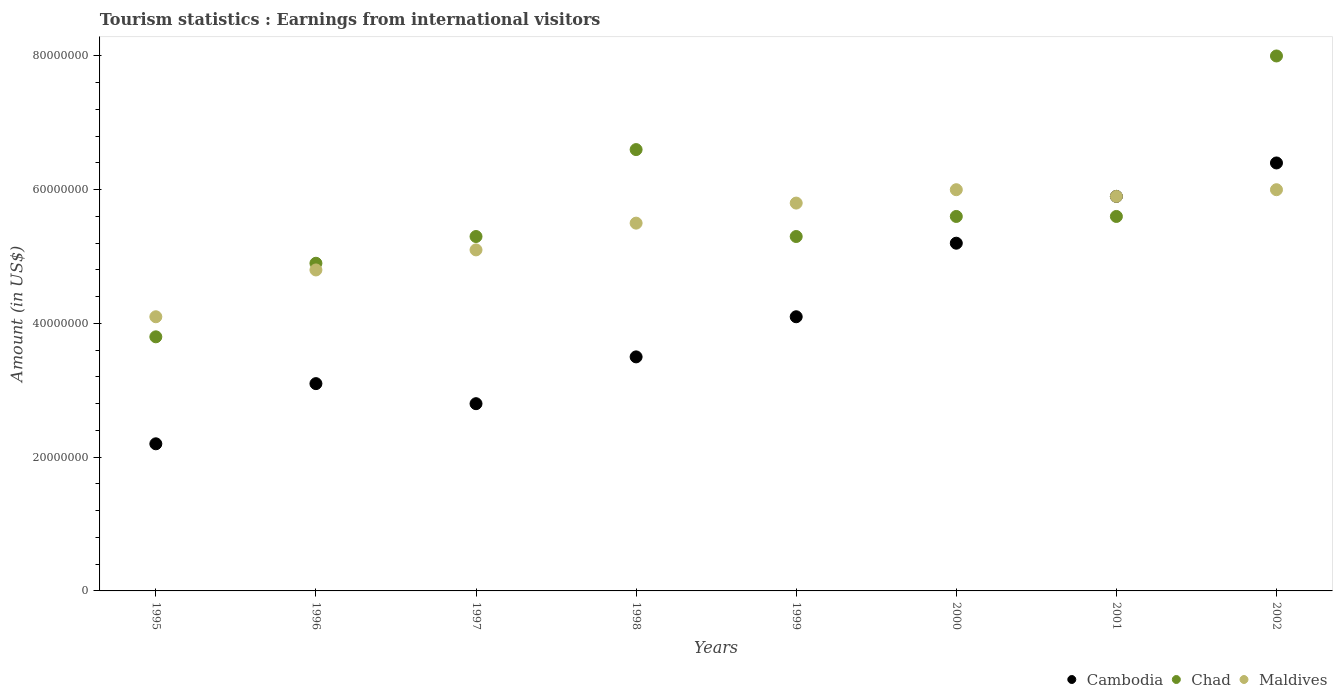How many different coloured dotlines are there?
Offer a terse response. 3. What is the earnings from international visitors in Cambodia in 2000?
Make the answer very short. 5.20e+07. Across all years, what is the maximum earnings from international visitors in Cambodia?
Keep it short and to the point. 6.40e+07. Across all years, what is the minimum earnings from international visitors in Chad?
Offer a very short reply. 3.80e+07. What is the total earnings from international visitors in Maldives in the graph?
Provide a short and direct response. 4.32e+08. What is the difference between the earnings from international visitors in Chad in 2000 and that in 2002?
Provide a short and direct response. -2.40e+07. What is the difference between the earnings from international visitors in Chad in 2001 and the earnings from international visitors in Cambodia in 1996?
Your answer should be compact. 2.50e+07. What is the average earnings from international visitors in Maldives per year?
Keep it short and to the point. 5.40e+07. In the year 1997, what is the difference between the earnings from international visitors in Maldives and earnings from international visitors in Chad?
Your response must be concise. -2.00e+06. In how many years, is the earnings from international visitors in Chad greater than 52000000 US$?
Ensure brevity in your answer.  6. What is the ratio of the earnings from international visitors in Maldives in 2001 to that in 2002?
Offer a very short reply. 0.98. What is the difference between the highest and the lowest earnings from international visitors in Maldives?
Ensure brevity in your answer.  1.90e+07. Is the sum of the earnings from international visitors in Maldives in 1995 and 1998 greater than the maximum earnings from international visitors in Cambodia across all years?
Your response must be concise. Yes. What is the difference between two consecutive major ticks on the Y-axis?
Your response must be concise. 2.00e+07. Does the graph contain grids?
Your response must be concise. No. How are the legend labels stacked?
Give a very brief answer. Horizontal. What is the title of the graph?
Offer a terse response. Tourism statistics : Earnings from international visitors. Does "Lower middle income" appear as one of the legend labels in the graph?
Keep it short and to the point. No. What is the label or title of the Y-axis?
Keep it short and to the point. Amount (in US$). What is the Amount (in US$) of Cambodia in 1995?
Your answer should be compact. 2.20e+07. What is the Amount (in US$) of Chad in 1995?
Offer a terse response. 3.80e+07. What is the Amount (in US$) in Maldives in 1995?
Your answer should be very brief. 4.10e+07. What is the Amount (in US$) in Cambodia in 1996?
Your response must be concise. 3.10e+07. What is the Amount (in US$) in Chad in 1996?
Ensure brevity in your answer.  4.90e+07. What is the Amount (in US$) of Maldives in 1996?
Make the answer very short. 4.80e+07. What is the Amount (in US$) in Cambodia in 1997?
Give a very brief answer. 2.80e+07. What is the Amount (in US$) in Chad in 1997?
Provide a succinct answer. 5.30e+07. What is the Amount (in US$) of Maldives in 1997?
Offer a very short reply. 5.10e+07. What is the Amount (in US$) in Cambodia in 1998?
Ensure brevity in your answer.  3.50e+07. What is the Amount (in US$) of Chad in 1998?
Provide a succinct answer. 6.60e+07. What is the Amount (in US$) in Maldives in 1998?
Give a very brief answer. 5.50e+07. What is the Amount (in US$) in Cambodia in 1999?
Offer a very short reply. 4.10e+07. What is the Amount (in US$) of Chad in 1999?
Your answer should be very brief. 5.30e+07. What is the Amount (in US$) of Maldives in 1999?
Offer a very short reply. 5.80e+07. What is the Amount (in US$) in Cambodia in 2000?
Your response must be concise. 5.20e+07. What is the Amount (in US$) of Chad in 2000?
Ensure brevity in your answer.  5.60e+07. What is the Amount (in US$) in Maldives in 2000?
Provide a short and direct response. 6.00e+07. What is the Amount (in US$) of Cambodia in 2001?
Ensure brevity in your answer.  5.90e+07. What is the Amount (in US$) of Chad in 2001?
Provide a succinct answer. 5.60e+07. What is the Amount (in US$) of Maldives in 2001?
Offer a very short reply. 5.90e+07. What is the Amount (in US$) of Cambodia in 2002?
Your answer should be very brief. 6.40e+07. What is the Amount (in US$) of Chad in 2002?
Your answer should be compact. 8.00e+07. What is the Amount (in US$) in Maldives in 2002?
Offer a very short reply. 6.00e+07. Across all years, what is the maximum Amount (in US$) of Cambodia?
Give a very brief answer. 6.40e+07. Across all years, what is the maximum Amount (in US$) of Chad?
Ensure brevity in your answer.  8.00e+07. Across all years, what is the maximum Amount (in US$) in Maldives?
Ensure brevity in your answer.  6.00e+07. Across all years, what is the minimum Amount (in US$) of Cambodia?
Offer a very short reply. 2.20e+07. Across all years, what is the minimum Amount (in US$) of Chad?
Your answer should be very brief. 3.80e+07. Across all years, what is the minimum Amount (in US$) of Maldives?
Your answer should be very brief. 4.10e+07. What is the total Amount (in US$) in Cambodia in the graph?
Your response must be concise. 3.32e+08. What is the total Amount (in US$) of Chad in the graph?
Your answer should be compact. 4.51e+08. What is the total Amount (in US$) of Maldives in the graph?
Offer a very short reply. 4.32e+08. What is the difference between the Amount (in US$) of Cambodia in 1995 and that in 1996?
Make the answer very short. -9.00e+06. What is the difference between the Amount (in US$) in Chad in 1995 and that in 1996?
Your answer should be compact. -1.10e+07. What is the difference between the Amount (in US$) of Maldives in 1995 and that in 1996?
Offer a very short reply. -7.00e+06. What is the difference between the Amount (in US$) of Cambodia in 1995 and that in 1997?
Give a very brief answer. -6.00e+06. What is the difference between the Amount (in US$) in Chad in 1995 and that in 1997?
Offer a terse response. -1.50e+07. What is the difference between the Amount (in US$) of Maldives in 1995 and that in 1997?
Keep it short and to the point. -1.00e+07. What is the difference between the Amount (in US$) of Cambodia in 1995 and that in 1998?
Your answer should be compact. -1.30e+07. What is the difference between the Amount (in US$) in Chad in 1995 and that in 1998?
Give a very brief answer. -2.80e+07. What is the difference between the Amount (in US$) in Maldives in 1995 and that in 1998?
Make the answer very short. -1.40e+07. What is the difference between the Amount (in US$) of Cambodia in 1995 and that in 1999?
Ensure brevity in your answer.  -1.90e+07. What is the difference between the Amount (in US$) of Chad in 1995 and that in 1999?
Your response must be concise. -1.50e+07. What is the difference between the Amount (in US$) in Maldives in 1995 and that in 1999?
Your answer should be compact. -1.70e+07. What is the difference between the Amount (in US$) of Cambodia in 1995 and that in 2000?
Provide a succinct answer. -3.00e+07. What is the difference between the Amount (in US$) in Chad in 1995 and that in 2000?
Make the answer very short. -1.80e+07. What is the difference between the Amount (in US$) in Maldives in 1995 and that in 2000?
Ensure brevity in your answer.  -1.90e+07. What is the difference between the Amount (in US$) in Cambodia in 1995 and that in 2001?
Your response must be concise. -3.70e+07. What is the difference between the Amount (in US$) of Chad in 1995 and that in 2001?
Provide a succinct answer. -1.80e+07. What is the difference between the Amount (in US$) of Maldives in 1995 and that in 2001?
Offer a terse response. -1.80e+07. What is the difference between the Amount (in US$) in Cambodia in 1995 and that in 2002?
Ensure brevity in your answer.  -4.20e+07. What is the difference between the Amount (in US$) of Chad in 1995 and that in 2002?
Provide a succinct answer. -4.20e+07. What is the difference between the Amount (in US$) of Maldives in 1995 and that in 2002?
Your answer should be very brief. -1.90e+07. What is the difference between the Amount (in US$) of Cambodia in 1996 and that in 1997?
Provide a short and direct response. 3.00e+06. What is the difference between the Amount (in US$) in Maldives in 1996 and that in 1997?
Your answer should be very brief. -3.00e+06. What is the difference between the Amount (in US$) of Chad in 1996 and that in 1998?
Provide a succinct answer. -1.70e+07. What is the difference between the Amount (in US$) in Maldives in 1996 and that in 1998?
Your answer should be compact. -7.00e+06. What is the difference between the Amount (in US$) in Cambodia in 1996 and that in 1999?
Your answer should be very brief. -1.00e+07. What is the difference between the Amount (in US$) in Maldives in 1996 and that in 1999?
Your response must be concise. -1.00e+07. What is the difference between the Amount (in US$) in Cambodia in 1996 and that in 2000?
Your answer should be very brief. -2.10e+07. What is the difference between the Amount (in US$) of Chad in 1996 and that in 2000?
Offer a very short reply. -7.00e+06. What is the difference between the Amount (in US$) in Maldives in 1996 and that in 2000?
Ensure brevity in your answer.  -1.20e+07. What is the difference between the Amount (in US$) of Cambodia in 1996 and that in 2001?
Provide a succinct answer. -2.80e+07. What is the difference between the Amount (in US$) of Chad in 1996 and that in 2001?
Your answer should be compact. -7.00e+06. What is the difference between the Amount (in US$) of Maldives in 1996 and that in 2001?
Offer a terse response. -1.10e+07. What is the difference between the Amount (in US$) in Cambodia in 1996 and that in 2002?
Give a very brief answer. -3.30e+07. What is the difference between the Amount (in US$) in Chad in 1996 and that in 2002?
Your answer should be very brief. -3.10e+07. What is the difference between the Amount (in US$) of Maldives in 1996 and that in 2002?
Provide a succinct answer. -1.20e+07. What is the difference between the Amount (in US$) of Cambodia in 1997 and that in 1998?
Your answer should be very brief. -7.00e+06. What is the difference between the Amount (in US$) in Chad in 1997 and that in 1998?
Ensure brevity in your answer.  -1.30e+07. What is the difference between the Amount (in US$) of Maldives in 1997 and that in 1998?
Ensure brevity in your answer.  -4.00e+06. What is the difference between the Amount (in US$) of Cambodia in 1997 and that in 1999?
Keep it short and to the point. -1.30e+07. What is the difference between the Amount (in US$) in Chad in 1997 and that in 1999?
Provide a short and direct response. 0. What is the difference between the Amount (in US$) of Maldives in 1997 and that in 1999?
Give a very brief answer. -7.00e+06. What is the difference between the Amount (in US$) of Cambodia in 1997 and that in 2000?
Offer a very short reply. -2.40e+07. What is the difference between the Amount (in US$) in Chad in 1997 and that in 2000?
Your answer should be compact. -3.00e+06. What is the difference between the Amount (in US$) in Maldives in 1997 and that in 2000?
Ensure brevity in your answer.  -9.00e+06. What is the difference between the Amount (in US$) in Cambodia in 1997 and that in 2001?
Provide a succinct answer. -3.10e+07. What is the difference between the Amount (in US$) in Maldives in 1997 and that in 2001?
Offer a very short reply. -8.00e+06. What is the difference between the Amount (in US$) in Cambodia in 1997 and that in 2002?
Offer a terse response. -3.60e+07. What is the difference between the Amount (in US$) of Chad in 1997 and that in 2002?
Provide a succinct answer. -2.70e+07. What is the difference between the Amount (in US$) of Maldives in 1997 and that in 2002?
Provide a short and direct response. -9.00e+06. What is the difference between the Amount (in US$) of Cambodia in 1998 and that in 1999?
Give a very brief answer. -6.00e+06. What is the difference between the Amount (in US$) in Chad in 1998 and that in 1999?
Provide a short and direct response. 1.30e+07. What is the difference between the Amount (in US$) of Cambodia in 1998 and that in 2000?
Provide a short and direct response. -1.70e+07. What is the difference between the Amount (in US$) of Chad in 1998 and that in 2000?
Make the answer very short. 1.00e+07. What is the difference between the Amount (in US$) of Maldives in 1998 and that in 2000?
Offer a very short reply. -5.00e+06. What is the difference between the Amount (in US$) in Cambodia in 1998 and that in 2001?
Make the answer very short. -2.40e+07. What is the difference between the Amount (in US$) of Chad in 1998 and that in 2001?
Your answer should be very brief. 1.00e+07. What is the difference between the Amount (in US$) of Cambodia in 1998 and that in 2002?
Make the answer very short. -2.90e+07. What is the difference between the Amount (in US$) in Chad in 1998 and that in 2002?
Your response must be concise. -1.40e+07. What is the difference between the Amount (in US$) of Maldives in 1998 and that in 2002?
Ensure brevity in your answer.  -5.00e+06. What is the difference between the Amount (in US$) in Cambodia in 1999 and that in 2000?
Offer a terse response. -1.10e+07. What is the difference between the Amount (in US$) of Chad in 1999 and that in 2000?
Offer a very short reply. -3.00e+06. What is the difference between the Amount (in US$) in Maldives in 1999 and that in 2000?
Your answer should be compact. -2.00e+06. What is the difference between the Amount (in US$) in Cambodia in 1999 and that in 2001?
Provide a short and direct response. -1.80e+07. What is the difference between the Amount (in US$) in Cambodia in 1999 and that in 2002?
Offer a very short reply. -2.30e+07. What is the difference between the Amount (in US$) of Chad in 1999 and that in 2002?
Provide a succinct answer. -2.70e+07. What is the difference between the Amount (in US$) in Cambodia in 2000 and that in 2001?
Ensure brevity in your answer.  -7.00e+06. What is the difference between the Amount (in US$) of Chad in 2000 and that in 2001?
Your response must be concise. 0. What is the difference between the Amount (in US$) of Cambodia in 2000 and that in 2002?
Provide a short and direct response. -1.20e+07. What is the difference between the Amount (in US$) of Chad in 2000 and that in 2002?
Offer a terse response. -2.40e+07. What is the difference between the Amount (in US$) in Maldives in 2000 and that in 2002?
Provide a short and direct response. 0. What is the difference between the Amount (in US$) of Cambodia in 2001 and that in 2002?
Give a very brief answer. -5.00e+06. What is the difference between the Amount (in US$) in Chad in 2001 and that in 2002?
Make the answer very short. -2.40e+07. What is the difference between the Amount (in US$) of Cambodia in 1995 and the Amount (in US$) of Chad in 1996?
Ensure brevity in your answer.  -2.70e+07. What is the difference between the Amount (in US$) in Cambodia in 1995 and the Amount (in US$) in Maldives in 1996?
Keep it short and to the point. -2.60e+07. What is the difference between the Amount (in US$) in Chad in 1995 and the Amount (in US$) in Maldives in 1996?
Offer a terse response. -1.00e+07. What is the difference between the Amount (in US$) in Cambodia in 1995 and the Amount (in US$) in Chad in 1997?
Give a very brief answer. -3.10e+07. What is the difference between the Amount (in US$) of Cambodia in 1995 and the Amount (in US$) of Maldives in 1997?
Ensure brevity in your answer.  -2.90e+07. What is the difference between the Amount (in US$) in Chad in 1995 and the Amount (in US$) in Maldives in 1997?
Offer a terse response. -1.30e+07. What is the difference between the Amount (in US$) of Cambodia in 1995 and the Amount (in US$) of Chad in 1998?
Make the answer very short. -4.40e+07. What is the difference between the Amount (in US$) in Cambodia in 1995 and the Amount (in US$) in Maldives in 1998?
Your answer should be very brief. -3.30e+07. What is the difference between the Amount (in US$) of Chad in 1995 and the Amount (in US$) of Maldives in 1998?
Your response must be concise. -1.70e+07. What is the difference between the Amount (in US$) of Cambodia in 1995 and the Amount (in US$) of Chad in 1999?
Provide a succinct answer. -3.10e+07. What is the difference between the Amount (in US$) in Cambodia in 1995 and the Amount (in US$) in Maldives in 1999?
Keep it short and to the point. -3.60e+07. What is the difference between the Amount (in US$) in Chad in 1995 and the Amount (in US$) in Maldives in 1999?
Provide a succinct answer. -2.00e+07. What is the difference between the Amount (in US$) in Cambodia in 1995 and the Amount (in US$) in Chad in 2000?
Provide a short and direct response. -3.40e+07. What is the difference between the Amount (in US$) of Cambodia in 1995 and the Amount (in US$) of Maldives in 2000?
Make the answer very short. -3.80e+07. What is the difference between the Amount (in US$) in Chad in 1995 and the Amount (in US$) in Maldives in 2000?
Your response must be concise. -2.20e+07. What is the difference between the Amount (in US$) of Cambodia in 1995 and the Amount (in US$) of Chad in 2001?
Your answer should be very brief. -3.40e+07. What is the difference between the Amount (in US$) in Cambodia in 1995 and the Amount (in US$) in Maldives in 2001?
Give a very brief answer. -3.70e+07. What is the difference between the Amount (in US$) in Chad in 1995 and the Amount (in US$) in Maldives in 2001?
Your answer should be very brief. -2.10e+07. What is the difference between the Amount (in US$) of Cambodia in 1995 and the Amount (in US$) of Chad in 2002?
Offer a terse response. -5.80e+07. What is the difference between the Amount (in US$) in Cambodia in 1995 and the Amount (in US$) in Maldives in 2002?
Provide a succinct answer. -3.80e+07. What is the difference between the Amount (in US$) in Chad in 1995 and the Amount (in US$) in Maldives in 2002?
Your answer should be compact. -2.20e+07. What is the difference between the Amount (in US$) in Cambodia in 1996 and the Amount (in US$) in Chad in 1997?
Offer a very short reply. -2.20e+07. What is the difference between the Amount (in US$) in Cambodia in 1996 and the Amount (in US$) in Maldives in 1997?
Make the answer very short. -2.00e+07. What is the difference between the Amount (in US$) in Cambodia in 1996 and the Amount (in US$) in Chad in 1998?
Keep it short and to the point. -3.50e+07. What is the difference between the Amount (in US$) of Cambodia in 1996 and the Amount (in US$) of Maldives in 1998?
Offer a very short reply. -2.40e+07. What is the difference between the Amount (in US$) of Chad in 1996 and the Amount (in US$) of Maldives in 1998?
Give a very brief answer. -6.00e+06. What is the difference between the Amount (in US$) in Cambodia in 1996 and the Amount (in US$) in Chad in 1999?
Offer a terse response. -2.20e+07. What is the difference between the Amount (in US$) of Cambodia in 1996 and the Amount (in US$) of Maldives in 1999?
Offer a terse response. -2.70e+07. What is the difference between the Amount (in US$) in Chad in 1996 and the Amount (in US$) in Maldives in 1999?
Offer a terse response. -9.00e+06. What is the difference between the Amount (in US$) in Cambodia in 1996 and the Amount (in US$) in Chad in 2000?
Your answer should be very brief. -2.50e+07. What is the difference between the Amount (in US$) in Cambodia in 1996 and the Amount (in US$) in Maldives in 2000?
Your response must be concise. -2.90e+07. What is the difference between the Amount (in US$) in Chad in 1996 and the Amount (in US$) in Maldives in 2000?
Ensure brevity in your answer.  -1.10e+07. What is the difference between the Amount (in US$) of Cambodia in 1996 and the Amount (in US$) of Chad in 2001?
Provide a short and direct response. -2.50e+07. What is the difference between the Amount (in US$) in Cambodia in 1996 and the Amount (in US$) in Maldives in 2001?
Provide a succinct answer. -2.80e+07. What is the difference between the Amount (in US$) in Chad in 1996 and the Amount (in US$) in Maldives in 2001?
Make the answer very short. -1.00e+07. What is the difference between the Amount (in US$) in Cambodia in 1996 and the Amount (in US$) in Chad in 2002?
Keep it short and to the point. -4.90e+07. What is the difference between the Amount (in US$) in Cambodia in 1996 and the Amount (in US$) in Maldives in 2002?
Your response must be concise. -2.90e+07. What is the difference between the Amount (in US$) in Chad in 1996 and the Amount (in US$) in Maldives in 2002?
Offer a terse response. -1.10e+07. What is the difference between the Amount (in US$) of Cambodia in 1997 and the Amount (in US$) of Chad in 1998?
Give a very brief answer. -3.80e+07. What is the difference between the Amount (in US$) in Cambodia in 1997 and the Amount (in US$) in Maldives in 1998?
Offer a very short reply. -2.70e+07. What is the difference between the Amount (in US$) in Cambodia in 1997 and the Amount (in US$) in Chad in 1999?
Keep it short and to the point. -2.50e+07. What is the difference between the Amount (in US$) of Cambodia in 1997 and the Amount (in US$) of Maldives in 1999?
Provide a succinct answer. -3.00e+07. What is the difference between the Amount (in US$) of Chad in 1997 and the Amount (in US$) of Maldives in 1999?
Offer a terse response. -5.00e+06. What is the difference between the Amount (in US$) in Cambodia in 1997 and the Amount (in US$) in Chad in 2000?
Offer a very short reply. -2.80e+07. What is the difference between the Amount (in US$) in Cambodia in 1997 and the Amount (in US$) in Maldives in 2000?
Provide a short and direct response. -3.20e+07. What is the difference between the Amount (in US$) in Chad in 1997 and the Amount (in US$) in Maldives in 2000?
Your answer should be very brief. -7.00e+06. What is the difference between the Amount (in US$) of Cambodia in 1997 and the Amount (in US$) of Chad in 2001?
Make the answer very short. -2.80e+07. What is the difference between the Amount (in US$) in Cambodia in 1997 and the Amount (in US$) in Maldives in 2001?
Give a very brief answer. -3.10e+07. What is the difference between the Amount (in US$) of Chad in 1997 and the Amount (in US$) of Maldives in 2001?
Provide a succinct answer. -6.00e+06. What is the difference between the Amount (in US$) in Cambodia in 1997 and the Amount (in US$) in Chad in 2002?
Your response must be concise. -5.20e+07. What is the difference between the Amount (in US$) in Cambodia in 1997 and the Amount (in US$) in Maldives in 2002?
Provide a short and direct response. -3.20e+07. What is the difference between the Amount (in US$) of Chad in 1997 and the Amount (in US$) of Maldives in 2002?
Ensure brevity in your answer.  -7.00e+06. What is the difference between the Amount (in US$) in Cambodia in 1998 and the Amount (in US$) in Chad in 1999?
Provide a short and direct response. -1.80e+07. What is the difference between the Amount (in US$) in Cambodia in 1998 and the Amount (in US$) in Maldives in 1999?
Your answer should be very brief. -2.30e+07. What is the difference between the Amount (in US$) in Chad in 1998 and the Amount (in US$) in Maldives in 1999?
Your response must be concise. 8.00e+06. What is the difference between the Amount (in US$) of Cambodia in 1998 and the Amount (in US$) of Chad in 2000?
Your answer should be very brief. -2.10e+07. What is the difference between the Amount (in US$) of Cambodia in 1998 and the Amount (in US$) of Maldives in 2000?
Give a very brief answer. -2.50e+07. What is the difference between the Amount (in US$) of Cambodia in 1998 and the Amount (in US$) of Chad in 2001?
Offer a terse response. -2.10e+07. What is the difference between the Amount (in US$) of Cambodia in 1998 and the Amount (in US$) of Maldives in 2001?
Offer a very short reply. -2.40e+07. What is the difference between the Amount (in US$) of Chad in 1998 and the Amount (in US$) of Maldives in 2001?
Your answer should be compact. 7.00e+06. What is the difference between the Amount (in US$) in Cambodia in 1998 and the Amount (in US$) in Chad in 2002?
Your answer should be compact. -4.50e+07. What is the difference between the Amount (in US$) in Cambodia in 1998 and the Amount (in US$) in Maldives in 2002?
Your answer should be very brief. -2.50e+07. What is the difference between the Amount (in US$) in Chad in 1998 and the Amount (in US$) in Maldives in 2002?
Offer a very short reply. 6.00e+06. What is the difference between the Amount (in US$) of Cambodia in 1999 and the Amount (in US$) of Chad in 2000?
Your answer should be compact. -1.50e+07. What is the difference between the Amount (in US$) of Cambodia in 1999 and the Amount (in US$) of Maldives in 2000?
Make the answer very short. -1.90e+07. What is the difference between the Amount (in US$) of Chad in 1999 and the Amount (in US$) of Maldives in 2000?
Offer a terse response. -7.00e+06. What is the difference between the Amount (in US$) of Cambodia in 1999 and the Amount (in US$) of Chad in 2001?
Give a very brief answer. -1.50e+07. What is the difference between the Amount (in US$) of Cambodia in 1999 and the Amount (in US$) of Maldives in 2001?
Ensure brevity in your answer.  -1.80e+07. What is the difference between the Amount (in US$) of Chad in 1999 and the Amount (in US$) of Maldives in 2001?
Ensure brevity in your answer.  -6.00e+06. What is the difference between the Amount (in US$) in Cambodia in 1999 and the Amount (in US$) in Chad in 2002?
Your response must be concise. -3.90e+07. What is the difference between the Amount (in US$) in Cambodia in 1999 and the Amount (in US$) in Maldives in 2002?
Offer a terse response. -1.90e+07. What is the difference between the Amount (in US$) in Chad in 1999 and the Amount (in US$) in Maldives in 2002?
Make the answer very short. -7.00e+06. What is the difference between the Amount (in US$) in Cambodia in 2000 and the Amount (in US$) in Maldives in 2001?
Ensure brevity in your answer.  -7.00e+06. What is the difference between the Amount (in US$) in Chad in 2000 and the Amount (in US$) in Maldives in 2001?
Keep it short and to the point. -3.00e+06. What is the difference between the Amount (in US$) in Cambodia in 2000 and the Amount (in US$) in Chad in 2002?
Offer a terse response. -2.80e+07. What is the difference between the Amount (in US$) of Cambodia in 2000 and the Amount (in US$) of Maldives in 2002?
Offer a very short reply. -8.00e+06. What is the difference between the Amount (in US$) in Cambodia in 2001 and the Amount (in US$) in Chad in 2002?
Ensure brevity in your answer.  -2.10e+07. What is the difference between the Amount (in US$) in Cambodia in 2001 and the Amount (in US$) in Maldives in 2002?
Ensure brevity in your answer.  -1.00e+06. What is the difference between the Amount (in US$) of Chad in 2001 and the Amount (in US$) of Maldives in 2002?
Give a very brief answer. -4.00e+06. What is the average Amount (in US$) in Cambodia per year?
Give a very brief answer. 4.15e+07. What is the average Amount (in US$) in Chad per year?
Offer a very short reply. 5.64e+07. What is the average Amount (in US$) in Maldives per year?
Offer a terse response. 5.40e+07. In the year 1995, what is the difference between the Amount (in US$) in Cambodia and Amount (in US$) in Chad?
Offer a terse response. -1.60e+07. In the year 1995, what is the difference between the Amount (in US$) of Cambodia and Amount (in US$) of Maldives?
Your response must be concise. -1.90e+07. In the year 1996, what is the difference between the Amount (in US$) in Cambodia and Amount (in US$) in Chad?
Ensure brevity in your answer.  -1.80e+07. In the year 1996, what is the difference between the Amount (in US$) in Cambodia and Amount (in US$) in Maldives?
Make the answer very short. -1.70e+07. In the year 1997, what is the difference between the Amount (in US$) of Cambodia and Amount (in US$) of Chad?
Your response must be concise. -2.50e+07. In the year 1997, what is the difference between the Amount (in US$) of Cambodia and Amount (in US$) of Maldives?
Provide a succinct answer. -2.30e+07. In the year 1997, what is the difference between the Amount (in US$) of Chad and Amount (in US$) of Maldives?
Offer a very short reply. 2.00e+06. In the year 1998, what is the difference between the Amount (in US$) in Cambodia and Amount (in US$) in Chad?
Your response must be concise. -3.10e+07. In the year 1998, what is the difference between the Amount (in US$) in Cambodia and Amount (in US$) in Maldives?
Your answer should be compact. -2.00e+07. In the year 1998, what is the difference between the Amount (in US$) in Chad and Amount (in US$) in Maldives?
Give a very brief answer. 1.10e+07. In the year 1999, what is the difference between the Amount (in US$) in Cambodia and Amount (in US$) in Chad?
Your answer should be very brief. -1.20e+07. In the year 1999, what is the difference between the Amount (in US$) of Cambodia and Amount (in US$) of Maldives?
Ensure brevity in your answer.  -1.70e+07. In the year 1999, what is the difference between the Amount (in US$) in Chad and Amount (in US$) in Maldives?
Give a very brief answer. -5.00e+06. In the year 2000, what is the difference between the Amount (in US$) in Cambodia and Amount (in US$) in Chad?
Your response must be concise. -4.00e+06. In the year 2000, what is the difference between the Amount (in US$) of Cambodia and Amount (in US$) of Maldives?
Keep it short and to the point. -8.00e+06. In the year 2001, what is the difference between the Amount (in US$) in Cambodia and Amount (in US$) in Maldives?
Offer a very short reply. 0. In the year 2001, what is the difference between the Amount (in US$) in Chad and Amount (in US$) in Maldives?
Your answer should be compact. -3.00e+06. In the year 2002, what is the difference between the Amount (in US$) in Cambodia and Amount (in US$) in Chad?
Make the answer very short. -1.60e+07. In the year 2002, what is the difference between the Amount (in US$) of Chad and Amount (in US$) of Maldives?
Provide a short and direct response. 2.00e+07. What is the ratio of the Amount (in US$) of Cambodia in 1995 to that in 1996?
Give a very brief answer. 0.71. What is the ratio of the Amount (in US$) in Chad in 1995 to that in 1996?
Provide a succinct answer. 0.78. What is the ratio of the Amount (in US$) in Maldives in 1995 to that in 1996?
Offer a very short reply. 0.85. What is the ratio of the Amount (in US$) of Cambodia in 1995 to that in 1997?
Provide a short and direct response. 0.79. What is the ratio of the Amount (in US$) in Chad in 1995 to that in 1997?
Keep it short and to the point. 0.72. What is the ratio of the Amount (in US$) of Maldives in 1995 to that in 1997?
Provide a succinct answer. 0.8. What is the ratio of the Amount (in US$) of Cambodia in 1995 to that in 1998?
Your answer should be very brief. 0.63. What is the ratio of the Amount (in US$) in Chad in 1995 to that in 1998?
Provide a succinct answer. 0.58. What is the ratio of the Amount (in US$) in Maldives in 1995 to that in 1998?
Offer a terse response. 0.75. What is the ratio of the Amount (in US$) in Cambodia in 1995 to that in 1999?
Offer a terse response. 0.54. What is the ratio of the Amount (in US$) in Chad in 1995 to that in 1999?
Your answer should be very brief. 0.72. What is the ratio of the Amount (in US$) of Maldives in 1995 to that in 1999?
Offer a very short reply. 0.71. What is the ratio of the Amount (in US$) of Cambodia in 1995 to that in 2000?
Keep it short and to the point. 0.42. What is the ratio of the Amount (in US$) in Chad in 1995 to that in 2000?
Offer a terse response. 0.68. What is the ratio of the Amount (in US$) of Maldives in 1995 to that in 2000?
Offer a terse response. 0.68. What is the ratio of the Amount (in US$) of Cambodia in 1995 to that in 2001?
Your answer should be very brief. 0.37. What is the ratio of the Amount (in US$) in Chad in 1995 to that in 2001?
Offer a terse response. 0.68. What is the ratio of the Amount (in US$) of Maldives in 1995 to that in 2001?
Ensure brevity in your answer.  0.69. What is the ratio of the Amount (in US$) in Cambodia in 1995 to that in 2002?
Make the answer very short. 0.34. What is the ratio of the Amount (in US$) of Chad in 1995 to that in 2002?
Offer a very short reply. 0.47. What is the ratio of the Amount (in US$) in Maldives in 1995 to that in 2002?
Provide a succinct answer. 0.68. What is the ratio of the Amount (in US$) of Cambodia in 1996 to that in 1997?
Offer a very short reply. 1.11. What is the ratio of the Amount (in US$) of Chad in 1996 to that in 1997?
Your response must be concise. 0.92. What is the ratio of the Amount (in US$) of Cambodia in 1996 to that in 1998?
Your response must be concise. 0.89. What is the ratio of the Amount (in US$) of Chad in 1996 to that in 1998?
Keep it short and to the point. 0.74. What is the ratio of the Amount (in US$) of Maldives in 1996 to that in 1998?
Your answer should be compact. 0.87. What is the ratio of the Amount (in US$) in Cambodia in 1996 to that in 1999?
Provide a short and direct response. 0.76. What is the ratio of the Amount (in US$) in Chad in 1996 to that in 1999?
Keep it short and to the point. 0.92. What is the ratio of the Amount (in US$) of Maldives in 1996 to that in 1999?
Give a very brief answer. 0.83. What is the ratio of the Amount (in US$) in Cambodia in 1996 to that in 2000?
Make the answer very short. 0.6. What is the ratio of the Amount (in US$) of Cambodia in 1996 to that in 2001?
Offer a terse response. 0.53. What is the ratio of the Amount (in US$) in Maldives in 1996 to that in 2001?
Your response must be concise. 0.81. What is the ratio of the Amount (in US$) of Cambodia in 1996 to that in 2002?
Offer a terse response. 0.48. What is the ratio of the Amount (in US$) of Chad in 1996 to that in 2002?
Your response must be concise. 0.61. What is the ratio of the Amount (in US$) of Maldives in 1996 to that in 2002?
Your answer should be compact. 0.8. What is the ratio of the Amount (in US$) of Chad in 1997 to that in 1998?
Make the answer very short. 0.8. What is the ratio of the Amount (in US$) in Maldives in 1997 to that in 1998?
Your answer should be very brief. 0.93. What is the ratio of the Amount (in US$) of Cambodia in 1997 to that in 1999?
Give a very brief answer. 0.68. What is the ratio of the Amount (in US$) of Maldives in 1997 to that in 1999?
Give a very brief answer. 0.88. What is the ratio of the Amount (in US$) in Cambodia in 1997 to that in 2000?
Your response must be concise. 0.54. What is the ratio of the Amount (in US$) of Chad in 1997 to that in 2000?
Provide a succinct answer. 0.95. What is the ratio of the Amount (in US$) of Maldives in 1997 to that in 2000?
Make the answer very short. 0.85. What is the ratio of the Amount (in US$) in Cambodia in 1997 to that in 2001?
Provide a short and direct response. 0.47. What is the ratio of the Amount (in US$) in Chad in 1997 to that in 2001?
Provide a short and direct response. 0.95. What is the ratio of the Amount (in US$) of Maldives in 1997 to that in 2001?
Offer a terse response. 0.86. What is the ratio of the Amount (in US$) of Cambodia in 1997 to that in 2002?
Offer a terse response. 0.44. What is the ratio of the Amount (in US$) in Chad in 1997 to that in 2002?
Your answer should be very brief. 0.66. What is the ratio of the Amount (in US$) of Maldives in 1997 to that in 2002?
Offer a very short reply. 0.85. What is the ratio of the Amount (in US$) in Cambodia in 1998 to that in 1999?
Make the answer very short. 0.85. What is the ratio of the Amount (in US$) in Chad in 1998 to that in 1999?
Offer a terse response. 1.25. What is the ratio of the Amount (in US$) of Maldives in 1998 to that in 1999?
Offer a terse response. 0.95. What is the ratio of the Amount (in US$) of Cambodia in 1998 to that in 2000?
Provide a short and direct response. 0.67. What is the ratio of the Amount (in US$) of Chad in 1998 to that in 2000?
Make the answer very short. 1.18. What is the ratio of the Amount (in US$) of Maldives in 1998 to that in 2000?
Provide a short and direct response. 0.92. What is the ratio of the Amount (in US$) of Cambodia in 1998 to that in 2001?
Offer a terse response. 0.59. What is the ratio of the Amount (in US$) in Chad in 1998 to that in 2001?
Provide a short and direct response. 1.18. What is the ratio of the Amount (in US$) in Maldives in 1998 to that in 2001?
Ensure brevity in your answer.  0.93. What is the ratio of the Amount (in US$) in Cambodia in 1998 to that in 2002?
Provide a short and direct response. 0.55. What is the ratio of the Amount (in US$) in Chad in 1998 to that in 2002?
Ensure brevity in your answer.  0.82. What is the ratio of the Amount (in US$) of Maldives in 1998 to that in 2002?
Your answer should be very brief. 0.92. What is the ratio of the Amount (in US$) in Cambodia in 1999 to that in 2000?
Provide a succinct answer. 0.79. What is the ratio of the Amount (in US$) in Chad in 1999 to that in 2000?
Your answer should be compact. 0.95. What is the ratio of the Amount (in US$) in Maldives in 1999 to that in 2000?
Provide a succinct answer. 0.97. What is the ratio of the Amount (in US$) in Cambodia in 1999 to that in 2001?
Your response must be concise. 0.69. What is the ratio of the Amount (in US$) of Chad in 1999 to that in 2001?
Ensure brevity in your answer.  0.95. What is the ratio of the Amount (in US$) of Maldives in 1999 to that in 2001?
Your response must be concise. 0.98. What is the ratio of the Amount (in US$) in Cambodia in 1999 to that in 2002?
Make the answer very short. 0.64. What is the ratio of the Amount (in US$) of Chad in 1999 to that in 2002?
Your answer should be very brief. 0.66. What is the ratio of the Amount (in US$) in Maldives in 1999 to that in 2002?
Provide a short and direct response. 0.97. What is the ratio of the Amount (in US$) of Cambodia in 2000 to that in 2001?
Provide a succinct answer. 0.88. What is the ratio of the Amount (in US$) of Maldives in 2000 to that in 2001?
Provide a succinct answer. 1.02. What is the ratio of the Amount (in US$) of Cambodia in 2000 to that in 2002?
Provide a succinct answer. 0.81. What is the ratio of the Amount (in US$) in Cambodia in 2001 to that in 2002?
Offer a very short reply. 0.92. What is the ratio of the Amount (in US$) of Chad in 2001 to that in 2002?
Provide a short and direct response. 0.7. What is the ratio of the Amount (in US$) of Maldives in 2001 to that in 2002?
Give a very brief answer. 0.98. What is the difference between the highest and the second highest Amount (in US$) in Cambodia?
Your answer should be compact. 5.00e+06. What is the difference between the highest and the second highest Amount (in US$) in Chad?
Ensure brevity in your answer.  1.40e+07. What is the difference between the highest and the lowest Amount (in US$) of Cambodia?
Ensure brevity in your answer.  4.20e+07. What is the difference between the highest and the lowest Amount (in US$) in Chad?
Give a very brief answer. 4.20e+07. What is the difference between the highest and the lowest Amount (in US$) of Maldives?
Provide a short and direct response. 1.90e+07. 